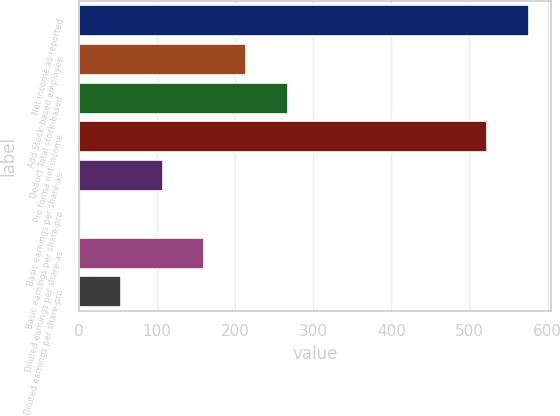Convert chart. <chart><loc_0><loc_0><loc_500><loc_500><bar_chart><fcel>Net income as reported<fcel>Add Stock-based employee<fcel>Deduct Total stock-based<fcel>Pro forma net income<fcel>Basic earnings per share-as<fcel>Basic earnings per share-pro<fcel>Diluted earnings per share-as<fcel>Diluted earnings per share-pro<nl><fcel>575.58<fcel>214.13<fcel>267.41<fcel>522.3<fcel>107.57<fcel>1.01<fcel>160.85<fcel>54.29<nl></chart> 